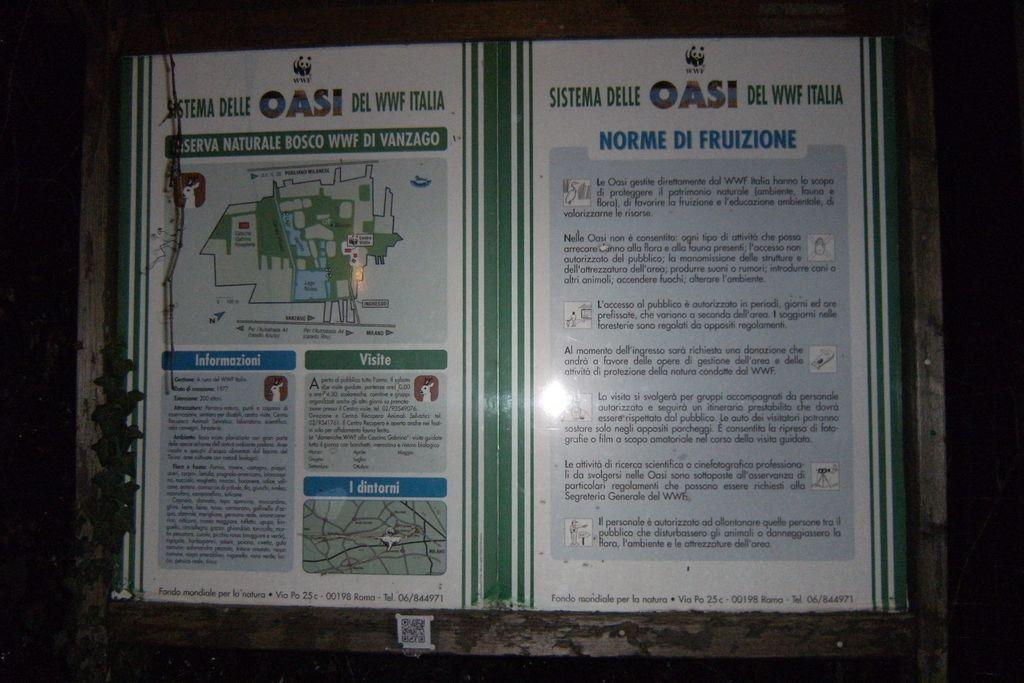<image>
Render a clear and concise summary of the photo. two pages of a box for OASI with a map and blue writing 